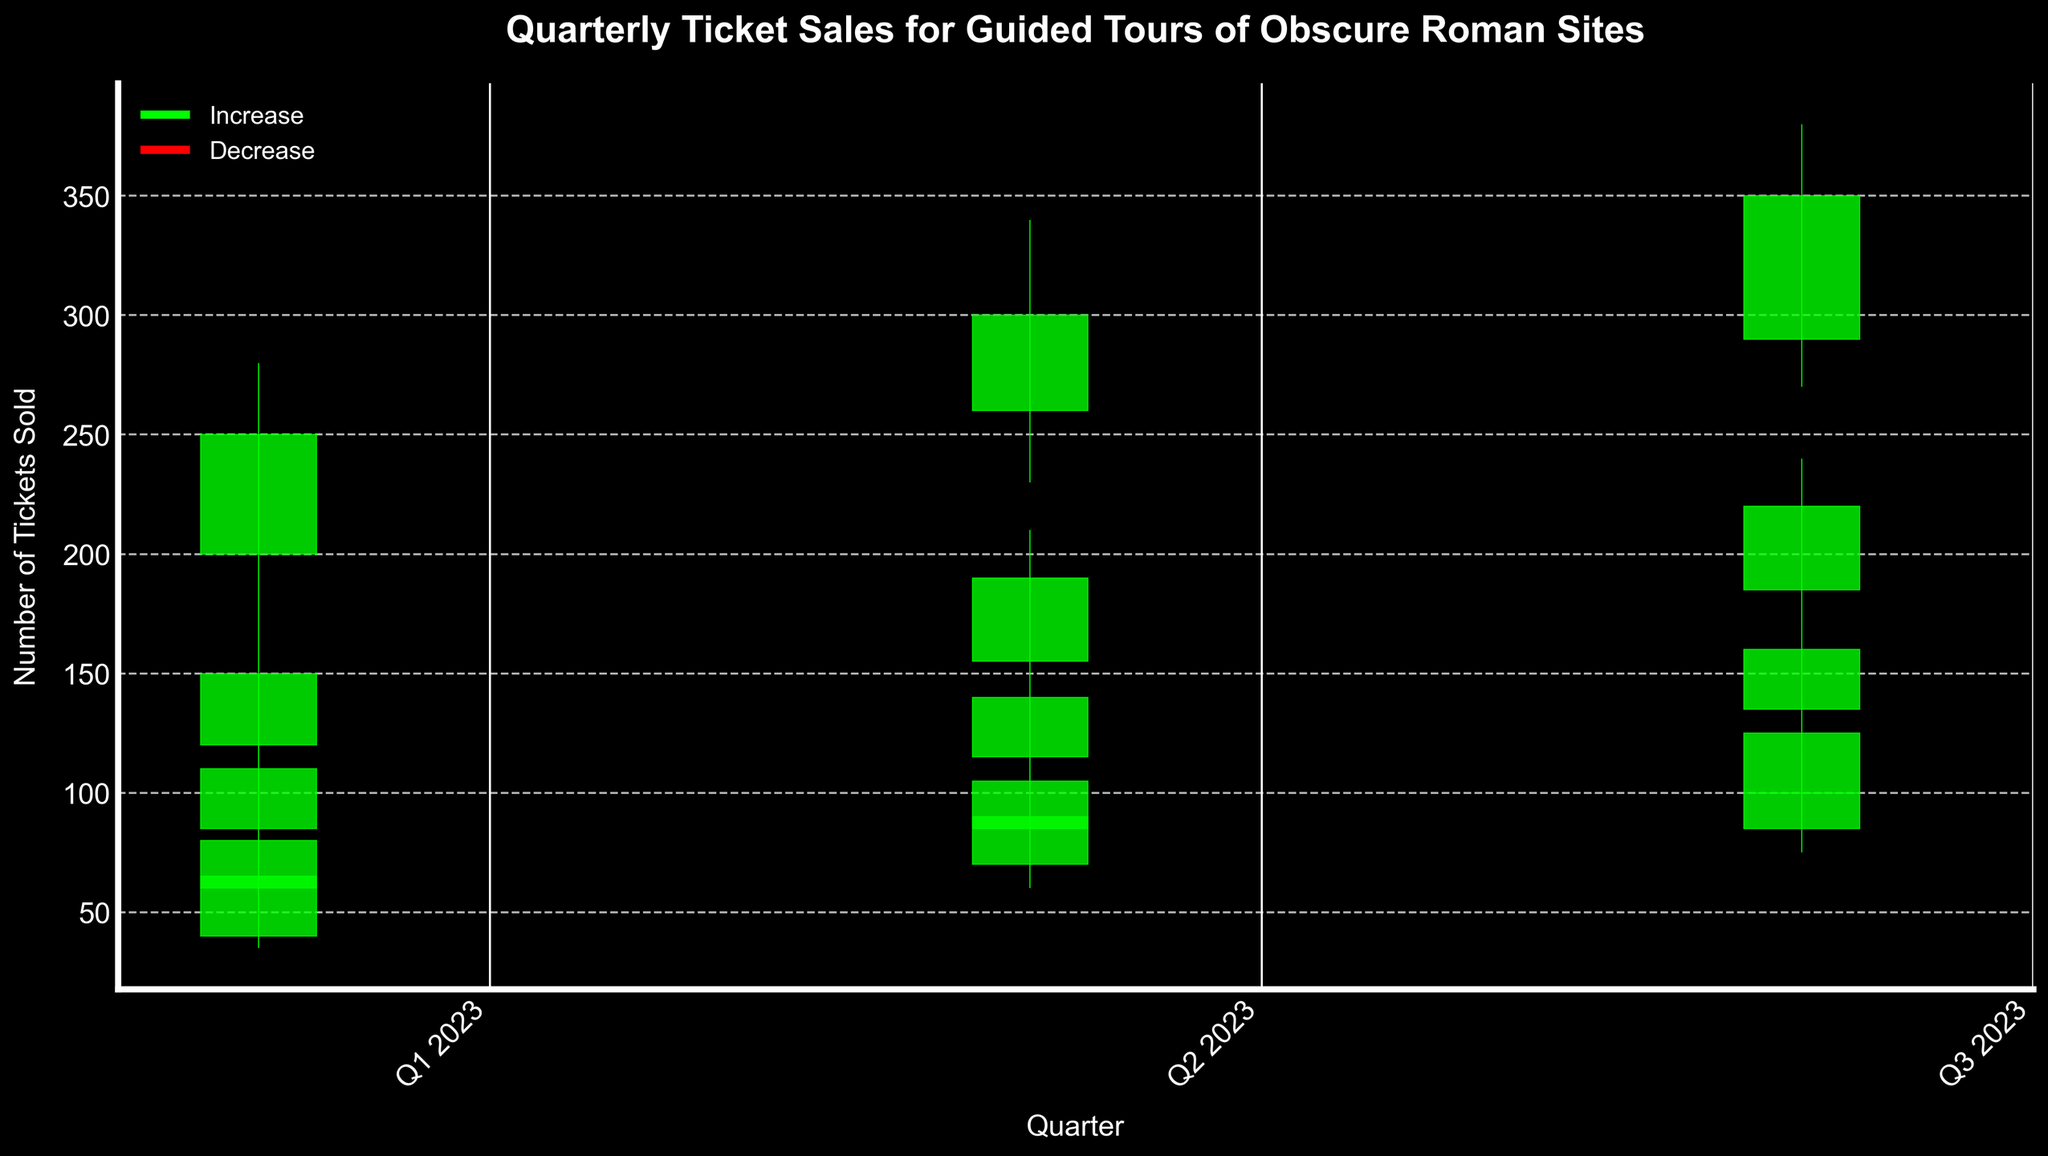What's the title of the chart? The title is usually located at the top of the chart. In this case, it is clearly indicated as "Quarterly Ticket Sales for Guided Tours of Obscure Roman Sites."
Answer: Quarterly Ticket Sales for Guided Tours of Obscure Roman Sites How many sites are represented in the chart? By examining the different colored candlesticks (each representing a different site), we can determine the number of unique sites on the x-axis. In this case, there are five unique Roman sites shown in the legend: Auditorium of Maecenas, Basilica of Junius Bassus, Domus Aurea, Necropolis of Via Triumphalis, and Vigna Barberini.
Answer: 5 Which site had the highest ticket sales in any quarter, and what was that figure? By focusing on the highest points (maxima) of the candlestick charts for each site, we can see that Domus Aurea had the highest sales, reaching 380 in Q3 2023.
Answer: Domus Aurea, 380 Which quarter had the greatest overall increase in ticket sales for the Auditorium of Maecenas? By comparing the difference between the opening and closing values of each quarter for the Auditorium of Maecenas on the chart shows: Q1 2023 (150-120=30), Q2 2023 (190-155=35), Q3 2023 (220-185=35). Q2 and Q3 2023 both had an increase of 35.
Answer: Q2 and Q3 2023 Which site had the most stable ticket sales in Q1 2023 and why? By comparing the range (highest - lowest) of sales figures for each site in Q1 2023, we can identify the site with the smallest range. The Vigna Barberini had the smallest range (75-35=40).
Answer: Vigna Barberini In which quarter did Vigna Barberini experience the largest decrease in ticket sales? By comparing the difference between the opening and closing values of each quarter for Vigna Barberini: Q1 2023 (65-40=25), Q2 2023 (90-70=20), and Q3 2023 (100-85=15). Q1 2023 had the most significant decrease of 25.
Answer: Q1 2023 What was the highest closing ticket sales figure for Basilica of Junius Bassus, and in which quarter was this achieved? By examining the closing values for Basilica of Junius Bassus across all quarters, we see the figures are: Q1 2023 (110), Q2 2023 (140), Q3 2023 (160). The highest closing value is 160 in Q3 2023.
Answer: 160, Q3 2023 What is the average highest ticket sales figure for Necropolis of Via Triumphalis over the three quarters? The highest ticket sales figures for Necropolis of Via Triumphalis are: Q1 2023 (95), Q2 2023 (120), Q3 2023 (140). Calculating the average: (95 + 120 + 140) / 3 = 118.33.
Answer: 118.33 Which quarter showed the lowest opening ticket sale for Domus Aurea, and what was the value? By examining the opening values for Domus Aurea across all quarters, we see the figures are: Q1 2023 (200), Q2 2023 (260), Q3 2023 (290). The lowest opening value is 200 in Q1 2023.
Answer: Q1 2023, 200 How many quarters experienced an increase in closing ticket sales for Necropolis of Via Triumphalis? By comparing the opening and closing values for Necropolis of Via Triumphalis: Q1 2023 (60 to 80), Q2 2023 (85 to 105), Q3 2023 (100 to 125), all three quarters show an increase in the closing value over the opening value.
Answer: 3 Which site had the smallest difference between the highest and lowest ticket sales in Q2 2023? By comparing the range (highest - lowest) for each site in Q2 2023: Auditorium of Maecenas (210-140=70), Basilica of Junius Bassus (165-100=65), Domus Aurea (340-230=110), Necropolis of Via Triumphalis (120-75=45), Vigna Barberini (100-60=40). The smallest difference is for Vigna Barberini with 40.
Answer: Vigna Barberini 